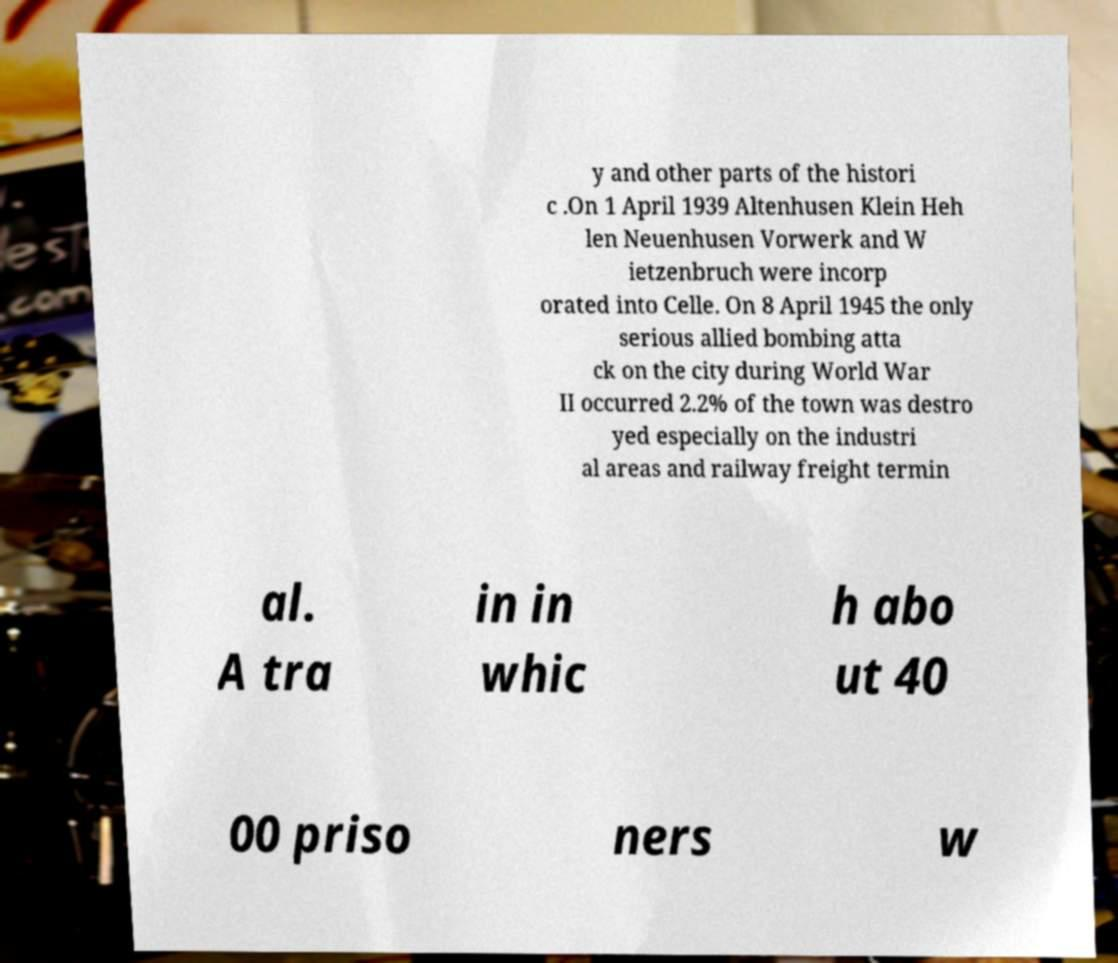Can you accurately transcribe the text from the provided image for me? y and other parts of the histori c .On 1 April 1939 Altenhusen Klein Heh len Neuenhusen Vorwerk and W ietzenbruch were incorp orated into Celle. On 8 April 1945 the only serious allied bombing atta ck on the city during World War II occurred 2.2% of the town was destro yed especially on the industri al areas and railway freight termin al. A tra in in whic h abo ut 40 00 priso ners w 